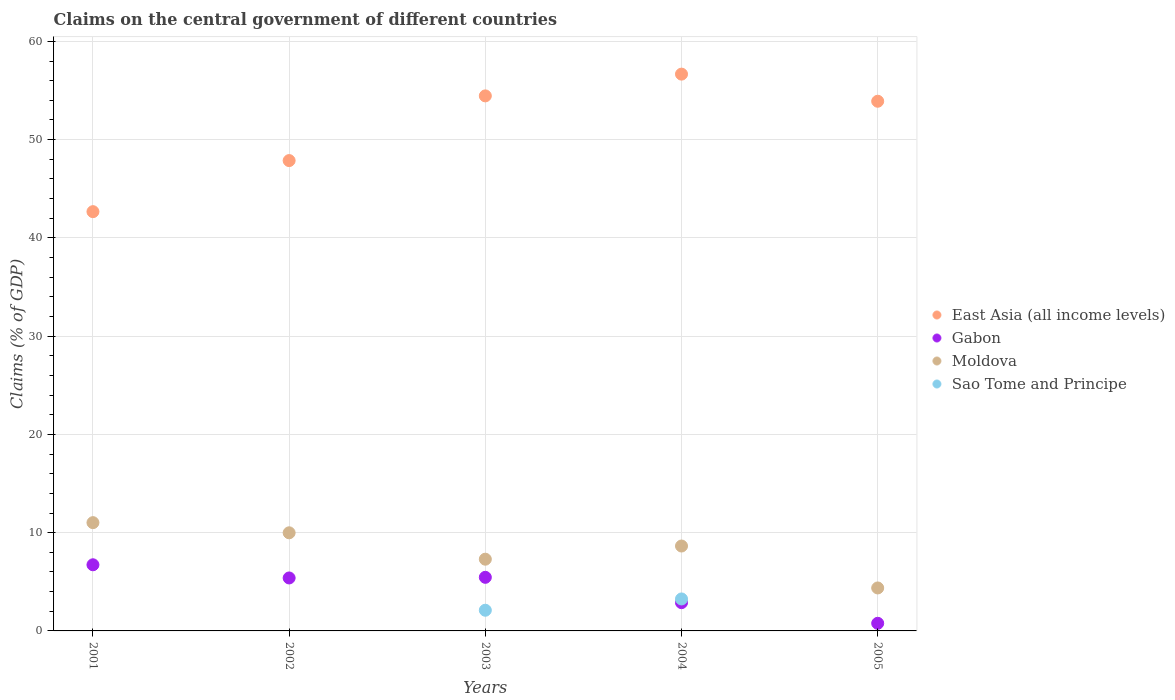What is the percentage of GDP claimed on the central government in Sao Tome and Principe in 2002?
Provide a succinct answer. 0. Across all years, what is the maximum percentage of GDP claimed on the central government in Moldova?
Keep it short and to the point. 11.02. Across all years, what is the minimum percentage of GDP claimed on the central government in Moldova?
Provide a short and direct response. 4.37. In which year was the percentage of GDP claimed on the central government in Moldova maximum?
Give a very brief answer. 2001. What is the total percentage of GDP claimed on the central government in Gabon in the graph?
Offer a very short reply. 21.23. What is the difference between the percentage of GDP claimed on the central government in Gabon in 2003 and that in 2005?
Your answer should be very brief. 4.68. What is the difference between the percentage of GDP claimed on the central government in East Asia (all income levels) in 2004 and the percentage of GDP claimed on the central government in Gabon in 2001?
Offer a very short reply. 49.93. What is the average percentage of GDP claimed on the central government in Moldova per year?
Give a very brief answer. 8.26. In the year 2003, what is the difference between the percentage of GDP claimed on the central government in Gabon and percentage of GDP claimed on the central government in Moldova?
Keep it short and to the point. -1.84. In how many years, is the percentage of GDP claimed on the central government in Sao Tome and Principe greater than 12 %?
Ensure brevity in your answer.  0. What is the ratio of the percentage of GDP claimed on the central government in East Asia (all income levels) in 2001 to that in 2005?
Provide a short and direct response. 0.79. Is the difference between the percentage of GDP claimed on the central government in Gabon in 2002 and 2005 greater than the difference between the percentage of GDP claimed on the central government in Moldova in 2002 and 2005?
Your answer should be very brief. No. What is the difference between the highest and the second highest percentage of GDP claimed on the central government in Moldova?
Your answer should be very brief. 1.03. What is the difference between the highest and the lowest percentage of GDP claimed on the central government in Gabon?
Make the answer very short. 5.96. In how many years, is the percentage of GDP claimed on the central government in Gabon greater than the average percentage of GDP claimed on the central government in Gabon taken over all years?
Keep it short and to the point. 3. Does the percentage of GDP claimed on the central government in East Asia (all income levels) monotonically increase over the years?
Your answer should be very brief. No. How many dotlines are there?
Give a very brief answer. 4. What is the difference between two consecutive major ticks on the Y-axis?
Ensure brevity in your answer.  10. Does the graph contain any zero values?
Offer a very short reply. Yes. Where does the legend appear in the graph?
Keep it short and to the point. Center right. How many legend labels are there?
Give a very brief answer. 4. How are the legend labels stacked?
Provide a succinct answer. Vertical. What is the title of the graph?
Your response must be concise. Claims on the central government of different countries. Does "Northern Mariana Islands" appear as one of the legend labels in the graph?
Your response must be concise. No. What is the label or title of the X-axis?
Provide a short and direct response. Years. What is the label or title of the Y-axis?
Provide a succinct answer. Claims (% of GDP). What is the Claims (% of GDP) in East Asia (all income levels) in 2001?
Your response must be concise. 42.67. What is the Claims (% of GDP) in Gabon in 2001?
Ensure brevity in your answer.  6.73. What is the Claims (% of GDP) of Moldova in 2001?
Make the answer very short. 11.02. What is the Claims (% of GDP) of East Asia (all income levels) in 2002?
Your answer should be very brief. 47.87. What is the Claims (% of GDP) of Gabon in 2002?
Ensure brevity in your answer.  5.39. What is the Claims (% of GDP) of Moldova in 2002?
Offer a very short reply. 9.99. What is the Claims (% of GDP) in East Asia (all income levels) in 2003?
Provide a succinct answer. 54.45. What is the Claims (% of GDP) in Gabon in 2003?
Offer a very short reply. 5.46. What is the Claims (% of GDP) of Moldova in 2003?
Your response must be concise. 7.3. What is the Claims (% of GDP) of Sao Tome and Principe in 2003?
Provide a short and direct response. 2.1. What is the Claims (% of GDP) of East Asia (all income levels) in 2004?
Provide a succinct answer. 56.67. What is the Claims (% of GDP) of Gabon in 2004?
Your answer should be very brief. 2.88. What is the Claims (% of GDP) in Moldova in 2004?
Ensure brevity in your answer.  8.64. What is the Claims (% of GDP) in Sao Tome and Principe in 2004?
Give a very brief answer. 3.25. What is the Claims (% of GDP) in East Asia (all income levels) in 2005?
Keep it short and to the point. 53.91. What is the Claims (% of GDP) of Gabon in 2005?
Offer a terse response. 0.78. What is the Claims (% of GDP) in Moldova in 2005?
Keep it short and to the point. 4.37. Across all years, what is the maximum Claims (% of GDP) in East Asia (all income levels)?
Your response must be concise. 56.67. Across all years, what is the maximum Claims (% of GDP) of Gabon?
Provide a succinct answer. 6.73. Across all years, what is the maximum Claims (% of GDP) of Moldova?
Make the answer very short. 11.02. Across all years, what is the maximum Claims (% of GDP) in Sao Tome and Principe?
Your answer should be compact. 3.25. Across all years, what is the minimum Claims (% of GDP) in East Asia (all income levels)?
Your answer should be very brief. 42.67. Across all years, what is the minimum Claims (% of GDP) in Gabon?
Provide a succinct answer. 0.78. Across all years, what is the minimum Claims (% of GDP) in Moldova?
Make the answer very short. 4.37. What is the total Claims (% of GDP) in East Asia (all income levels) in the graph?
Offer a very short reply. 255.56. What is the total Claims (% of GDP) of Gabon in the graph?
Make the answer very short. 21.23. What is the total Claims (% of GDP) of Moldova in the graph?
Your answer should be compact. 41.32. What is the total Claims (% of GDP) in Sao Tome and Principe in the graph?
Your answer should be compact. 5.36. What is the difference between the Claims (% of GDP) in East Asia (all income levels) in 2001 and that in 2002?
Make the answer very short. -5.2. What is the difference between the Claims (% of GDP) of Gabon in 2001 and that in 2002?
Your response must be concise. 1.34. What is the difference between the Claims (% of GDP) of Moldova in 2001 and that in 2002?
Offer a terse response. 1.03. What is the difference between the Claims (% of GDP) of East Asia (all income levels) in 2001 and that in 2003?
Your answer should be very brief. -11.78. What is the difference between the Claims (% of GDP) of Gabon in 2001 and that in 2003?
Offer a terse response. 1.28. What is the difference between the Claims (% of GDP) of Moldova in 2001 and that in 2003?
Provide a succinct answer. 3.72. What is the difference between the Claims (% of GDP) in East Asia (all income levels) in 2001 and that in 2004?
Your answer should be compact. -14. What is the difference between the Claims (% of GDP) of Gabon in 2001 and that in 2004?
Make the answer very short. 3.86. What is the difference between the Claims (% of GDP) of Moldova in 2001 and that in 2004?
Offer a very short reply. 2.38. What is the difference between the Claims (% of GDP) of East Asia (all income levels) in 2001 and that in 2005?
Provide a short and direct response. -11.24. What is the difference between the Claims (% of GDP) in Gabon in 2001 and that in 2005?
Give a very brief answer. 5.96. What is the difference between the Claims (% of GDP) of Moldova in 2001 and that in 2005?
Give a very brief answer. 6.65. What is the difference between the Claims (% of GDP) in East Asia (all income levels) in 2002 and that in 2003?
Provide a short and direct response. -6.58. What is the difference between the Claims (% of GDP) in Gabon in 2002 and that in 2003?
Your answer should be compact. -0.07. What is the difference between the Claims (% of GDP) in Moldova in 2002 and that in 2003?
Provide a short and direct response. 2.69. What is the difference between the Claims (% of GDP) in East Asia (all income levels) in 2002 and that in 2004?
Provide a short and direct response. -8.8. What is the difference between the Claims (% of GDP) of Gabon in 2002 and that in 2004?
Offer a terse response. 2.51. What is the difference between the Claims (% of GDP) of Moldova in 2002 and that in 2004?
Offer a terse response. 1.35. What is the difference between the Claims (% of GDP) of East Asia (all income levels) in 2002 and that in 2005?
Give a very brief answer. -6.04. What is the difference between the Claims (% of GDP) of Gabon in 2002 and that in 2005?
Provide a succinct answer. 4.61. What is the difference between the Claims (% of GDP) of Moldova in 2002 and that in 2005?
Give a very brief answer. 5.61. What is the difference between the Claims (% of GDP) in East Asia (all income levels) in 2003 and that in 2004?
Provide a succinct answer. -2.21. What is the difference between the Claims (% of GDP) of Gabon in 2003 and that in 2004?
Provide a short and direct response. 2.58. What is the difference between the Claims (% of GDP) in Moldova in 2003 and that in 2004?
Provide a succinct answer. -1.34. What is the difference between the Claims (% of GDP) in Sao Tome and Principe in 2003 and that in 2004?
Make the answer very short. -1.15. What is the difference between the Claims (% of GDP) of East Asia (all income levels) in 2003 and that in 2005?
Give a very brief answer. 0.55. What is the difference between the Claims (% of GDP) in Gabon in 2003 and that in 2005?
Make the answer very short. 4.68. What is the difference between the Claims (% of GDP) in Moldova in 2003 and that in 2005?
Ensure brevity in your answer.  2.93. What is the difference between the Claims (% of GDP) in East Asia (all income levels) in 2004 and that in 2005?
Your response must be concise. 2.76. What is the difference between the Claims (% of GDP) of Gabon in 2004 and that in 2005?
Your response must be concise. 2.1. What is the difference between the Claims (% of GDP) of Moldova in 2004 and that in 2005?
Ensure brevity in your answer.  4.27. What is the difference between the Claims (% of GDP) in East Asia (all income levels) in 2001 and the Claims (% of GDP) in Gabon in 2002?
Keep it short and to the point. 37.28. What is the difference between the Claims (% of GDP) of East Asia (all income levels) in 2001 and the Claims (% of GDP) of Moldova in 2002?
Provide a succinct answer. 32.68. What is the difference between the Claims (% of GDP) in Gabon in 2001 and the Claims (% of GDP) in Moldova in 2002?
Ensure brevity in your answer.  -3.25. What is the difference between the Claims (% of GDP) of East Asia (all income levels) in 2001 and the Claims (% of GDP) of Gabon in 2003?
Give a very brief answer. 37.21. What is the difference between the Claims (% of GDP) in East Asia (all income levels) in 2001 and the Claims (% of GDP) in Moldova in 2003?
Make the answer very short. 35.37. What is the difference between the Claims (% of GDP) in East Asia (all income levels) in 2001 and the Claims (% of GDP) in Sao Tome and Principe in 2003?
Offer a terse response. 40.56. What is the difference between the Claims (% of GDP) in Gabon in 2001 and the Claims (% of GDP) in Moldova in 2003?
Keep it short and to the point. -0.57. What is the difference between the Claims (% of GDP) in Gabon in 2001 and the Claims (% of GDP) in Sao Tome and Principe in 2003?
Provide a short and direct response. 4.63. What is the difference between the Claims (% of GDP) of Moldova in 2001 and the Claims (% of GDP) of Sao Tome and Principe in 2003?
Your answer should be compact. 8.91. What is the difference between the Claims (% of GDP) in East Asia (all income levels) in 2001 and the Claims (% of GDP) in Gabon in 2004?
Provide a succinct answer. 39.79. What is the difference between the Claims (% of GDP) of East Asia (all income levels) in 2001 and the Claims (% of GDP) of Moldova in 2004?
Provide a short and direct response. 34.03. What is the difference between the Claims (% of GDP) of East Asia (all income levels) in 2001 and the Claims (% of GDP) of Sao Tome and Principe in 2004?
Make the answer very short. 39.42. What is the difference between the Claims (% of GDP) of Gabon in 2001 and the Claims (% of GDP) of Moldova in 2004?
Provide a succinct answer. -1.91. What is the difference between the Claims (% of GDP) of Gabon in 2001 and the Claims (% of GDP) of Sao Tome and Principe in 2004?
Your answer should be very brief. 3.48. What is the difference between the Claims (% of GDP) of Moldova in 2001 and the Claims (% of GDP) of Sao Tome and Principe in 2004?
Ensure brevity in your answer.  7.77. What is the difference between the Claims (% of GDP) in East Asia (all income levels) in 2001 and the Claims (% of GDP) in Gabon in 2005?
Provide a succinct answer. 41.89. What is the difference between the Claims (% of GDP) of East Asia (all income levels) in 2001 and the Claims (% of GDP) of Moldova in 2005?
Provide a short and direct response. 38.3. What is the difference between the Claims (% of GDP) of Gabon in 2001 and the Claims (% of GDP) of Moldova in 2005?
Provide a short and direct response. 2.36. What is the difference between the Claims (% of GDP) of East Asia (all income levels) in 2002 and the Claims (% of GDP) of Gabon in 2003?
Give a very brief answer. 42.41. What is the difference between the Claims (% of GDP) in East Asia (all income levels) in 2002 and the Claims (% of GDP) in Moldova in 2003?
Keep it short and to the point. 40.57. What is the difference between the Claims (% of GDP) in East Asia (all income levels) in 2002 and the Claims (% of GDP) in Sao Tome and Principe in 2003?
Your response must be concise. 45.76. What is the difference between the Claims (% of GDP) of Gabon in 2002 and the Claims (% of GDP) of Moldova in 2003?
Your response must be concise. -1.91. What is the difference between the Claims (% of GDP) in Gabon in 2002 and the Claims (% of GDP) in Sao Tome and Principe in 2003?
Keep it short and to the point. 3.29. What is the difference between the Claims (% of GDP) in Moldova in 2002 and the Claims (% of GDP) in Sao Tome and Principe in 2003?
Give a very brief answer. 7.88. What is the difference between the Claims (% of GDP) of East Asia (all income levels) in 2002 and the Claims (% of GDP) of Gabon in 2004?
Your answer should be compact. 44.99. What is the difference between the Claims (% of GDP) in East Asia (all income levels) in 2002 and the Claims (% of GDP) in Moldova in 2004?
Offer a very short reply. 39.23. What is the difference between the Claims (% of GDP) in East Asia (all income levels) in 2002 and the Claims (% of GDP) in Sao Tome and Principe in 2004?
Provide a short and direct response. 44.61. What is the difference between the Claims (% of GDP) of Gabon in 2002 and the Claims (% of GDP) of Moldova in 2004?
Offer a very short reply. -3.25. What is the difference between the Claims (% of GDP) of Gabon in 2002 and the Claims (% of GDP) of Sao Tome and Principe in 2004?
Offer a very short reply. 2.14. What is the difference between the Claims (% of GDP) of Moldova in 2002 and the Claims (% of GDP) of Sao Tome and Principe in 2004?
Provide a succinct answer. 6.73. What is the difference between the Claims (% of GDP) in East Asia (all income levels) in 2002 and the Claims (% of GDP) in Gabon in 2005?
Your answer should be compact. 47.09. What is the difference between the Claims (% of GDP) in East Asia (all income levels) in 2002 and the Claims (% of GDP) in Moldova in 2005?
Your response must be concise. 43.49. What is the difference between the Claims (% of GDP) of Gabon in 2002 and the Claims (% of GDP) of Moldova in 2005?
Ensure brevity in your answer.  1.02. What is the difference between the Claims (% of GDP) of East Asia (all income levels) in 2003 and the Claims (% of GDP) of Gabon in 2004?
Your answer should be compact. 51.57. What is the difference between the Claims (% of GDP) in East Asia (all income levels) in 2003 and the Claims (% of GDP) in Moldova in 2004?
Provide a short and direct response. 45.81. What is the difference between the Claims (% of GDP) in East Asia (all income levels) in 2003 and the Claims (% of GDP) in Sao Tome and Principe in 2004?
Your answer should be compact. 51.2. What is the difference between the Claims (% of GDP) in Gabon in 2003 and the Claims (% of GDP) in Moldova in 2004?
Offer a very short reply. -3.19. What is the difference between the Claims (% of GDP) in Gabon in 2003 and the Claims (% of GDP) in Sao Tome and Principe in 2004?
Provide a succinct answer. 2.2. What is the difference between the Claims (% of GDP) of Moldova in 2003 and the Claims (% of GDP) of Sao Tome and Principe in 2004?
Provide a short and direct response. 4.05. What is the difference between the Claims (% of GDP) in East Asia (all income levels) in 2003 and the Claims (% of GDP) in Gabon in 2005?
Keep it short and to the point. 53.68. What is the difference between the Claims (% of GDP) of East Asia (all income levels) in 2003 and the Claims (% of GDP) of Moldova in 2005?
Provide a succinct answer. 50.08. What is the difference between the Claims (% of GDP) of Gabon in 2003 and the Claims (% of GDP) of Moldova in 2005?
Your answer should be compact. 1.08. What is the difference between the Claims (% of GDP) of East Asia (all income levels) in 2004 and the Claims (% of GDP) of Gabon in 2005?
Offer a very short reply. 55.89. What is the difference between the Claims (% of GDP) in East Asia (all income levels) in 2004 and the Claims (% of GDP) in Moldova in 2005?
Offer a very short reply. 52.29. What is the difference between the Claims (% of GDP) in Gabon in 2004 and the Claims (% of GDP) in Moldova in 2005?
Offer a terse response. -1.5. What is the average Claims (% of GDP) of East Asia (all income levels) per year?
Offer a very short reply. 51.11. What is the average Claims (% of GDP) in Gabon per year?
Offer a terse response. 4.25. What is the average Claims (% of GDP) in Moldova per year?
Offer a very short reply. 8.26. What is the average Claims (% of GDP) in Sao Tome and Principe per year?
Make the answer very short. 1.07. In the year 2001, what is the difference between the Claims (% of GDP) of East Asia (all income levels) and Claims (% of GDP) of Gabon?
Provide a succinct answer. 35.94. In the year 2001, what is the difference between the Claims (% of GDP) in East Asia (all income levels) and Claims (% of GDP) in Moldova?
Keep it short and to the point. 31.65. In the year 2001, what is the difference between the Claims (% of GDP) of Gabon and Claims (% of GDP) of Moldova?
Provide a short and direct response. -4.29. In the year 2002, what is the difference between the Claims (% of GDP) of East Asia (all income levels) and Claims (% of GDP) of Gabon?
Provide a succinct answer. 42.48. In the year 2002, what is the difference between the Claims (% of GDP) in East Asia (all income levels) and Claims (% of GDP) in Moldova?
Make the answer very short. 37.88. In the year 2002, what is the difference between the Claims (% of GDP) in Gabon and Claims (% of GDP) in Moldova?
Give a very brief answer. -4.6. In the year 2003, what is the difference between the Claims (% of GDP) of East Asia (all income levels) and Claims (% of GDP) of Gabon?
Ensure brevity in your answer.  49. In the year 2003, what is the difference between the Claims (% of GDP) in East Asia (all income levels) and Claims (% of GDP) in Moldova?
Make the answer very short. 47.15. In the year 2003, what is the difference between the Claims (% of GDP) of East Asia (all income levels) and Claims (% of GDP) of Sao Tome and Principe?
Your answer should be very brief. 52.35. In the year 2003, what is the difference between the Claims (% of GDP) in Gabon and Claims (% of GDP) in Moldova?
Your answer should be very brief. -1.84. In the year 2003, what is the difference between the Claims (% of GDP) in Gabon and Claims (% of GDP) in Sao Tome and Principe?
Provide a short and direct response. 3.35. In the year 2003, what is the difference between the Claims (% of GDP) in Moldova and Claims (% of GDP) in Sao Tome and Principe?
Your response must be concise. 5.19. In the year 2004, what is the difference between the Claims (% of GDP) of East Asia (all income levels) and Claims (% of GDP) of Gabon?
Keep it short and to the point. 53.79. In the year 2004, what is the difference between the Claims (% of GDP) in East Asia (all income levels) and Claims (% of GDP) in Moldova?
Make the answer very short. 48.02. In the year 2004, what is the difference between the Claims (% of GDP) in East Asia (all income levels) and Claims (% of GDP) in Sao Tome and Principe?
Your response must be concise. 53.41. In the year 2004, what is the difference between the Claims (% of GDP) in Gabon and Claims (% of GDP) in Moldova?
Offer a terse response. -5.76. In the year 2004, what is the difference between the Claims (% of GDP) of Gabon and Claims (% of GDP) of Sao Tome and Principe?
Offer a very short reply. -0.38. In the year 2004, what is the difference between the Claims (% of GDP) in Moldova and Claims (% of GDP) in Sao Tome and Principe?
Provide a succinct answer. 5.39. In the year 2005, what is the difference between the Claims (% of GDP) of East Asia (all income levels) and Claims (% of GDP) of Gabon?
Your response must be concise. 53.13. In the year 2005, what is the difference between the Claims (% of GDP) in East Asia (all income levels) and Claims (% of GDP) in Moldova?
Ensure brevity in your answer.  49.53. In the year 2005, what is the difference between the Claims (% of GDP) of Gabon and Claims (% of GDP) of Moldova?
Make the answer very short. -3.6. What is the ratio of the Claims (% of GDP) of East Asia (all income levels) in 2001 to that in 2002?
Give a very brief answer. 0.89. What is the ratio of the Claims (% of GDP) of Gabon in 2001 to that in 2002?
Give a very brief answer. 1.25. What is the ratio of the Claims (% of GDP) of Moldova in 2001 to that in 2002?
Your answer should be compact. 1.1. What is the ratio of the Claims (% of GDP) of East Asia (all income levels) in 2001 to that in 2003?
Keep it short and to the point. 0.78. What is the ratio of the Claims (% of GDP) in Gabon in 2001 to that in 2003?
Provide a succinct answer. 1.23. What is the ratio of the Claims (% of GDP) of Moldova in 2001 to that in 2003?
Give a very brief answer. 1.51. What is the ratio of the Claims (% of GDP) of East Asia (all income levels) in 2001 to that in 2004?
Give a very brief answer. 0.75. What is the ratio of the Claims (% of GDP) in Gabon in 2001 to that in 2004?
Make the answer very short. 2.34. What is the ratio of the Claims (% of GDP) in Moldova in 2001 to that in 2004?
Your answer should be very brief. 1.28. What is the ratio of the Claims (% of GDP) of East Asia (all income levels) in 2001 to that in 2005?
Provide a succinct answer. 0.79. What is the ratio of the Claims (% of GDP) of Gabon in 2001 to that in 2005?
Your response must be concise. 8.68. What is the ratio of the Claims (% of GDP) in Moldova in 2001 to that in 2005?
Offer a very short reply. 2.52. What is the ratio of the Claims (% of GDP) of East Asia (all income levels) in 2002 to that in 2003?
Ensure brevity in your answer.  0.88. What is the ratio of the Claims (% of GDP) of Moldova in 2002 to that in 2003?
Keep it short and to the point. 1.37. What is the ratio of the Claims (% of GDP) in East Asia (all income levels) in 2002 to that in 2004?
Keep it short and to the point. 0.84. What is the ratio of the Claims (% of GDP) in Gabon in 2002 to that in 2004?
Provide a succinct answer. 1.87. What is the ratio of the Claims (% of GDP) of Moldova in 2002 to that in 2004?
Give a very brief answer. 1.16. What is the ratio of the Claims (% of GDP) of East Asia (all income levels) in 2002 to that in 2005?
Keep it short and to the point. 0.89. What is the ratio of the Claims (% of GDP) of Gabon in 2002 to that in 2005?
Your response must be concise. 6.95. What is the ratio of the Claims (% of GDP) in Moldova in 2002 to that in 2005?
Offer a very short reply. 2.28. What is the ratio of the Claims (% of GDP) in East Asia (all income levels) in 2003 to that in 2004?
Give a very brief answer. 0.96. What is the ratio of the Claims (% of GDP) in Gabon in 2003 to that in 2004?
Make the answer very short. 1.9. What is the ratio of the Claims (% of GDP) of Moldova in 2003 to that in 2004?
Offer a very short reply. 0.84. What is the ratio of the Claims (% of GDP) in Sao Tome and Principe in 2003 to that in 2004?
Offer a terse response. 0.65. What is the ratio of the Claims (% of GDP) of Gabon in 2003 to that in 2005?
Your answer should be compact. 7.03. What is the ratio of the Claims (% of GDP) in Moldova in 2003 to that in 2005?
Your answer should be very brief. 1.67. What is the ratio of the Claims (% of GDP) in East Asia (all income levels) in 2004 to that in 2005?
Ensure brevity in your answer.  1.05. What is the ratio of the Claims (% of GDP) of Gabon in 2004 to that in 2005?
Provide a succinct answer. 3.71. What is the ratio of the Claims (% of GDP) of Moldova in 2004 to that in 2005?
Keep it short and to the point. 1.98. What is the difference between the highest and the second highest Claims (% of GDP) in East Asia (all income levels)?
Your response must be concise. 2.21. What is the difference between the highest and the second highest Claims (% of GDP) of Gabon?
Give a very brief answer. 1.28. What is the difference between the highest and the second highest Claims (% of GDP) of Moldova?
Ensure brevity in your answer.  1.03. What is the difference between the highest and the lowest Claims (% of GDP) of East Asia (all income levels)?
Your answer should be very brief. 14. What is the difference between the highest and the lowest Claims (% of GDP) of Gabon?
Ensure brevity in your answer.  5.96. What is the difference between the highest and the lowest Claims (% of GDP) in Moldova?
Provide a succinct answer. 6.65. What is the difference between the highest and the lowest Claims (% of GDP) in Sao Tome and Principe?
Your answer should be very brief. 3.25. 